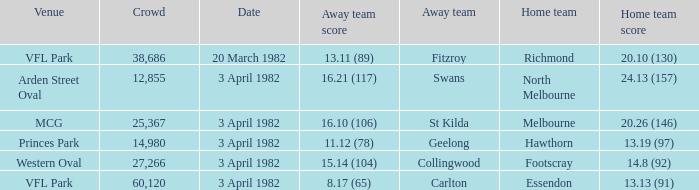What score did the home team of north melbourne get? 24.13 (157). 